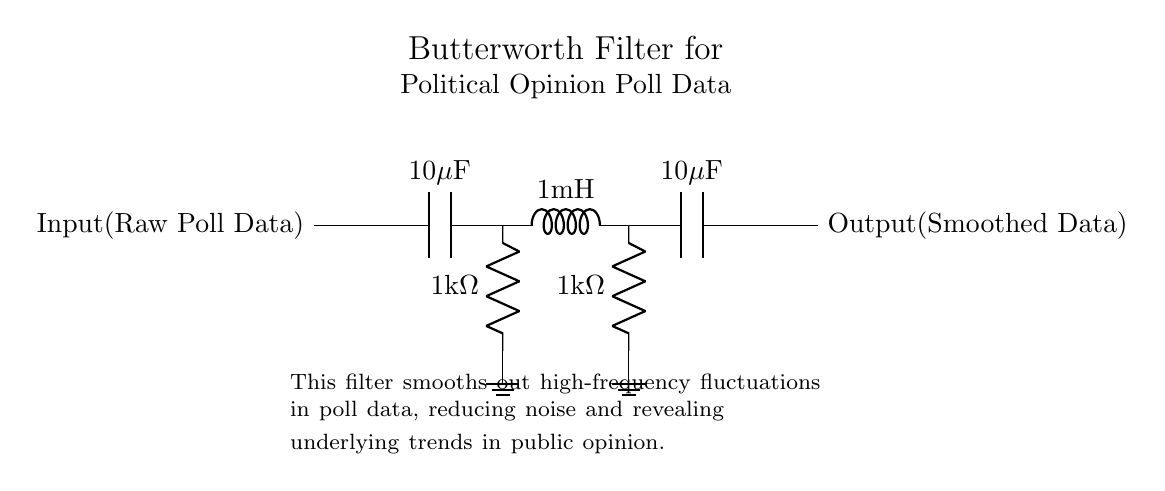What is the input of the circuit? The input of the circuit is labeled as "Raw Poll Data," representing the unfiltered and raw data coming from opinion polls.
Answer: Raw Poll Data What types of components are used in this Butterworth filter? The circuit includes capacitors, inductors, and resistors, which are standard components for a Butterworth filter aimed at smoothing signals.
Answer: Capacitors, inductors, and resistors What is the value of the capacitors in the circuit? The circuit features two capacitors, each with a value of ten microfarads, as indicated by the labels on the capacitors in the diagram.
Answer: Ten microfarads How does this filter affect the high-frequency fluctuations? The Butterworth filter is designed to smooth out high-frequency fluctuations in the poll data, effectively reducing noise and revealing underlying trends.
Answer: Smoothing out high-frequency fluctuations What is the output of the circuit? The output of the circuit is labeled as "Smoothed Data," which indicates the processed and filtered version of the input raw poll data.
Answer: Smoothed Data What is the resistance value of the resistors in the circuit? The diagram indicates that there are two resistors in the circuit, each with a resistance value of one kilohm, as shown in the label next to each resistor.
Answer: One kilohm How many components are in series in the filtering path? The filtering path includes three components in series—the capacitors and inductor—connected consecutively before the output is taken.
Answer: Three components 